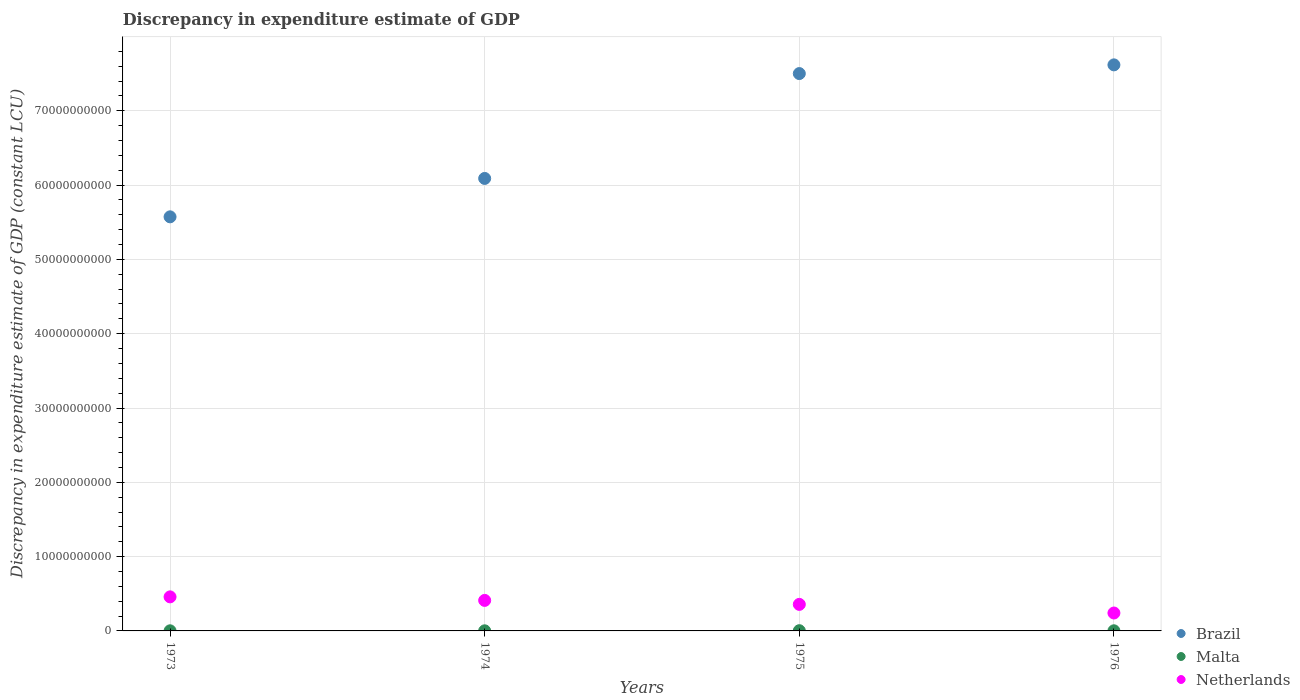How many different coloured dotlines are there?
Ensure brevity in your answer.  3. Is the number of dotlines equal to the number of legend labels?
Your answer should be very brief. Yes. What is the discrepancy in expenditure estimate of GDP in Brazil in 1973?
Your response must be concise. 5.57e+1. Across all years, what is the maximum discrepancy in expenditure estimate of GDP in Netherlands?
Your answer should be compact. 4.58e+09. Across all years, what is the minimum discrepancy in expenditure estimate of GDP in Malta?
Offer a terse response. 1.47e+07. In which year was the discrepancy in expenditure estimate of GDP in Netherlands maximum?
Offer a terse response. 1973. In which year was the discrepancy in expenditure estimate of GDP in Brazil minimum?
Provide a succinct answer. 1973. What is the total discrepancy in expenditure estimate of GDP in Brazil in the graph?
Provide a short and direct response. 2.68e+11. What is the difference between the discrepancy in expenditure estimate of GDP in Netherlands in 1973 and that in 1975?
Offer a terse response. 1.01e+09. What is the difference between the discrepancy in expenditure estimate of GDP in Malta in 1973 and the discrepancy in expenditure estimate of GDP in Netherlands in 1974?
Keep it short and to the point. -4.09e+09. What is the average discrepancy in expenditure estimate of GDP in Netherlands per year?
Ensure brevity in your answer.  3.67e+09. In the year 1976, what is the difference between the discrepancy in expenditure estimate of GDP in Netherlands and discrepancy in expenditure estimate of GDP in Brazil?
Offer a very short reply. -7.38e+1. In how many years, is the discrepancy in expenditure estimate of GDP in Netherlands greater than 66000000000 LCU?
Your response must be concise. 0. What is the ratio of the discrepancy in expenditure estimate of GDP in Malta in 1975 to that in 1976?
Your answer should be very brief. 1.71. Is the difference between the discrepancy in expenditure estimate of GDP in Netherlands in 1973 and 1974 greater than the difference between the discrepancy in expenditure estimate of GDP in Brazil in 1973 and 1974?
Provide a short and direct response. Yes. What is the difference between the highest and the second highest discrepancy in expenditure estimate of GDP in Netherlands?
Keep it short and to the point. 4.76e+08. What is the difference between the highest and the lowest discrepancy in expenditure estimate of GDP in Malta?
Keep it short and to the point. 1.52e+07. In how many years, is the discrepancy in expenditure estimate of GDP in Malta greater than the average discrepancy in expenditure estimate of GDP in Malta taken over all years?
Offer a terse response. 1. Is the sum of the discrepancy in expenditure estimate of GDP in Malta in 1974 and 1976 greater than the maximum discrepancy in expenditure estimate of GDP in Netherlands across all years?
Make the answer very short. No. Is the discrepancy in expenditure estimate of GDP in Netherlands strictly less than the discrepancy in expenditure estimate of GDP in Malta over the years?
Ensure brevity in your answer.  No. How many years are there in the graph?
Your answer should be very brief. 4. Does the graph contain any zero values?
Offer a terse response. No. Does the graph contain grids?
Your answer should be very brief. Yes. Where does the legend appear in the graph?
Ensure brevity in your answer.  Bottom right. How many legend labels are there?
Ensure brevity in your answer.  3. How are the legend labels stacked?
Your answer should be compact. Vertical. What is the title of the graph?
Keep it short and to the point. Discrepancy in expenditure estimate of GDP. Does "Algeria" appear as one of the legend labels in the graph?
Provide a succinct answer. No. What is the label or title of the Y-axis?
Offer a terse response. Discrepancy in expenditure estimate of GDP (constant LCU). What is the Discrepancy in expenditure estimate of GDP (constant LCU) in Brazil in 1973?
Your answer should be compact. 5.57e+1. What is the Discrepancy in expenditure estimate of GDP (constant LCU) in Malta in 1973?
Offer a terse response. 1.58e+07. What is the Discrepancy in expenditure estimate of GDP (constant LCU) of Netherlands in 1973?
Offer a very short reply. 4.58e+09. What is the Discrepancy in expenditure estimate of GDP (constant LCU) in Brazil in 1974?
Provide a succinct answer. 6.09e+1. What is the Discrepancy in expenditure estimate of GDP (constant LCU) of Malta in 1974?
Offer a very short reply. 1.47e+07. What is the Discrepancy in expenditure estimate of GDP (constant LCU) of Netherlands in 1974?
Keep it short and to the point. 4.11e+09. What is the Discrepancy in expenditure estimate of GDP (constant LCU) in Brazil in 1975?
Provide a short and direct response. 7.50e+1. What is the Discrepancy in expenditure estimate of GDP (constant LCU) of Malta in 1975?
Offer a very short reply. 2.99e+07. What is the Discrepancy in expenditure estimate of GDP (constant LCU) of Netherlands in 1975?
Provide a short and direct response. 3.57e+09. What is the Discrepancy in expenditure estimate of GDP (constant LCU) of Brazil in 1976?
Provide a succinct answer. 7.62e+1. What is the Discrepancy in expenditure estimate of GDP (constant LCU) of Malta in 1976?
Provide a short and direct response. 1.75e+07. What is the Discrepancy in expenditure estimate of GDP (constant LCU) in Netherlands in 1976?
Make the answer very short. 2.41e+09. Across all years, what is the maximum Discrepancy in expenditure estimate of GDP (constant LCU) of Brazil?
Provide a short and direct response. 7.62e+1. Across all years, what is the maximum Discrepancy in expenditure estimate of GDP (constant LCU) in Malta?
Offer a terse response. 2.99e+07. Across all years, what is the maximum Discrepancy in expenditure estimate of GDP (constant LCU) of Netherlands?
Your answer should be compact. 4.58e+09. Across all years, what is the minimum Discrepancy in expenditure estimate of GDP (constant LCU) of Brazil?
Provide a succinct answer. 5.57e+1. Across all years, what is the minimum Discrepancy in expenditure estimate of GDP (constant LCU) of Malta?
Your response must be concise. 1.47e+07. Across all years, what is the minimum Discrepancy in expenditure estimate of GDP (constant LCU) of Netherlands?
Your answer should be very brief. 2.41e+09. What is the total Discrepancy in expenditure estimate of GDP (constant LCU) in Brazil in the graph?
Give a very brief answer. 2.68e+11. What is the total Discrepancy in expenditure estimate of GDP (constant LCU) in Malta in the graph?
Offer a very short reply. 7.80e+07. What is the total Discrepancy in expenditure estimate of GDP (constant LCU) of Netherlands in the graph?
Keep it short and to the point. 1.47e+1. What is the difference between the Discrepancy in expenditure estimate of GDP (constant LCU) in Brazil in 1973 and that in 1974?
Your answer should be compact. -5.17e+09. What is the difference between the Discrepancy in expenditure estimate of GDP (constant LCU) in Malta in 1973 and that in 1974?
Give a very brief answer. 1.12e+06. What is the difference between the Discrepancy in expenditure estimate of GDP (constant LCU) in Netherlands in 1973 and that in 1974?
Give a very brief answer. 4.76e+08. What is the difference between the Discrepancy in expenditure estimate of GDP (constant LCU) of Brazil in 1973 and that in 1975?
Provide a succinct answer. -1.93e+1. What is the difference between the Discrepancy in expenditure estimate of GDP (constant LCU) of Malta in 1973 and that in 1975?
Your answer should be very brief. -1.41e+07. What is the difference between the Discrepancy in expenditure estimate of GDP (constant LCU) in Netherlands in 1973 and that in 1975?
Offer a very short reply. 1.01e+09. What is the difference between the Discrepancy in expenditure estimate of GDP (constant LCU) of Brazil in 1973 and that in 1976?
Make the answer very short. -2.05e+1. What is the difference between the Discrepancy in expenditure estimate of GDP (constant LCU) of Malta in 1973 and that in 1976?
Give a very brief answer. -1.66e+06. What is the difference between the Discrepancy in expenditure estimate of GDP (constant LCU) of Netherlands in 1973 and that in 1976?
Your answer should be very brief. 2.17e+09. What is the difference between the Discrepancy in expenditure estimate of GDP (constant LCU) in Brazil in 1974 and that in 1975?
Provide a succinct answer. -1.41e+1. What is the difference between the Discrepancy in expenditure estimate of GDP (constant LCU) in Malta in 1974 and that in 1975?
Offer a very short reply. -1.52e+07. What is the difference between the Discrepancy in expenditure estimate of GDP (constant LCU) of Netherlands in 1974 and that in 1975?
Give a very brief answer. 5.35e+08. What is the difference between the Discrepancy in expenditure estimate of GDP (constant LCU) of Brazil in 1974 and that in 1976?
Make the answer very short. -1.53e+1. What is the difference between the Discrepancy in expenditure estimate of GDP (constant LCU) of Malta in 1974 and that in 1976?
Keep it short and to the point. -2.79e+06. What is the difference between the Discrepancy in expenditure estimate of GDP (constant LCU) in Netherlands in 1974 and that in 1976?
Keep it short and to the point. 1.70e+09. What is the difference between the Discrepancy in expenditure estimate of GDP (constant LCU) of Brazil in 1975 and that in 1976?
Provide a succinct answer. -1.17e+09. What is the difference between the Discrepancy in expenditure estimate of GDP (constant LCU) in Malta in 1975 and that in 1976?
Your answer should be very brief. 1.24e+07. What is the difference between the Discrepancy in expenditure estimate of GDP (constant LCU) in Netherlands in 1975 and that in 1976?
Give a very brief answer. 1.16e+09. What is the difference between the Discrepancy in expenditure estimate of GDP (constant LCU) in Brazil in 1973 and the Discrepancy in expenditure estimate of GDP (constant LCU) in Malta in 1974?
Your answer should be compact. 5.57e+1. What is the difference between the Discrepancy in expenditure estimate of GDP (constant LCU) of Brazil in 1973 and the Discrepancy in expenditure estimate of GDP (constant LCU) of Netherlands in 1974?
Give a very brief answer. 5.16e+1. What is the difference between the Discrepancy in expenditure estimate of GDP (constant LCU) of Malta in 1973 and the Discrepancy in expenditure estimate of GDP (constant LCU) of Netherlands in 1974?
Provide a succinct answer. -4.09e+09. What is the difference between the Discrepancy in expenditure estimate of GDP (constant LCU) in Brazil in 1973 and the Discrepancy in expenditure estimate of GDP (constant LCU) in Malta in 1975?
Offer a very short reply. 5.57e+1. What is the difference between the Discrepancy in expenditure estimate of GDP (constant LCU) in Brazil in 1973 and the Discrepancy in expenditure estimate of GDP (constant LCU) in Netherlands in 1975?
Offer a terse response. 5.22e+1. What is the difference between the Discrepancy in expenditure estimate of GDP (constant LCU) in Malta in 1973 and the Discrepancy in expenditure estimate of GDP (constant LCU) in Netherlands in 1975?
Make the answer very short. -3.56e+09. What is the difference between the Discrepancy in expenditure estimate of GDP (constant LCU) of Brazil in 1973 and the Discrepancy in expenditure estimate of GDP (constant LCU) of Malta in 1976?
Offer a very short reply. 5.57e+1. What is the difference between the Discrepancy in expenditure estimate of GDP (constant LCU) of Brazil in 1973 and the Discrepancy in expenditure estimate of GDP (constant LCU) of Netherlands in 1976?
Your answer should be compact. 5.33e+1. What is the difference between the Discrepancy in expenditure estimate of GDP (constant LCU) of Malta in 1973 and the Discrepancy in expenditure estimate of GDP (constant LCU) of Netherlands in 1976?
Make the answer very short. -2.39e+09. What is the difference between the Discrepancy in expenditure estimate of GDP (constant LCU) of Brazil in 1974 and the Discrepancy in expenditure estimate of GDP (constant LCU) of Malta in 1975?
Ensure brevity in your answer.  6.09e+1. What is the difference between the Discrepancy in expenditure estimate of GDP (constant LCU) in Brazil in 1974 and the Discrepancy in expenditure estimate of GDP (constant LCU) in Netherlands in 1975?
Provide a short and direct response. 5.73e+1. What is the difference between the Discrepancy in expenditure estimate of GDP (constant LCU) of Malta in 1974 and the Discrepancy in expenditure estimate of GDP (constant LCU) of Netherlands in 1975?
Offer a very short reply. -3.56e+09. What is the difference between the Discrepancy in expenditure estimate of GDP (constant LCU) in Brazil in 1974 and the Discrepancy in expenditure estimate of GDP (constant LCU) in Malta in 1976?
Provide a succinct answer. 6.09e+1. What is the difference between the Discrepancy in expenditure estimate of GDP (constant LCU) in Brazil in 1974 and the Discrepancy in expenditure estimate of GDP (constant LCU) in Netherlands in 1976?
Offer a very short reply. 5.85e+1. What is the difference between the Discrepancy in expenditure estimate of GDP (constant LCU) in Malta in 1974 and the Discrepancy in expenditure estimate of GDP (constant LCU) in Netherlands in 1976?
Offer a terse response. -2.40e+09. What is the difference between the Discrepancy in expenditure estimate of GDP (constant LCU) in Brazil in 1975 and the Discrepancy in expenditure estimate of GDP (constant LCU) in Malta in 1976?
Offer a very short reply. 7.50e+1. What is the difference between the Discrepancy in expenditure estimate of GDP (constant LCU) in Brazil in 1975 and the Discrepancy in expenditure estimate of GDP (constant LCU) in Netherlands in 1976?
Offer a very short reply. 7.26e+1. What is the difference between the Discrepancy in expenditure estimate of GDP (constant LCU) of Malta in 1975 and the Discrepancy in expenditure estimate of GDP (constant LCU) of Netherlands in 1976?
Your answer should be very brief. -2.38e+09. What is the average Discrepancy in expenditure estimate of GDP (constant LCU) of Brazil per year?
Ensure brevity in your answer.  6.70e+1. What is the average Discrepancy in expenditure estimate of GDP (constant LCU) in Malta per year?
Provide a short and direct response. 1.95e+07. What is the average Discrepancy in expenditure estimate of GDP (constant LCU) of Netherlands per year?
Give a very brief answer. 3.67e+09. In the year 1973, what is the difference between the Discrepancy in expenditure estimate of GDP (constant LCU) in Brazil and Discrepancy in expenditure estimate of GDP (constant LCU) in Malta?
Make the answer very short. 5.57e+1. In the year 1973, what is the difference between the Discrepancy in expenditure estimate of GDP (constant LCU) of Brazil and Discrepancy in expenditure estimate of GDP (constant LCU) of Netherlands?
Provide a short and direct response. 5.11e+1. In the year 1973, what is the difference between the Discrepancy in expenditure estimate of GDP (constant LCU) of Malta and Discrepancy in expenditure estimate of GDP (constant LCU) of Netherlands?
Provide a short and direct response. -4.57e+09. In the year 1974, what is the difference between the Discrepancy in expenditure estimate of GDP (constant LCU) in Brazil and Discrepancy in expenditure estimate of GDP (constant LCU) in Malta?
Provide a short and direct response. 6.09e+1. In the year 1974, what is the difference between the Discrepancy in expenditure estimate of GDP (constant LCU) of Brazil and Discrepancy in expenditure estimate of GDP (constant LCU) of Netherlands?
Make the answer very short. 5.68e+1. In the year 1974, what is the difference between the Discrepancy in expenditure estimate of GDP (constant LCU) of Malta and Discrepancy in expenditure estimate of GDP (constant LCU) of Netherlands?
Keep it short and to the point. -4.09e+09. In the year 1975, what is the difference between the Discrepancy in expenditure estimate of GDP (constant LCU) in Brazil and Discrepancy in expenditure estimate of GDP (constant LCU) in Malta?
Offer a very short reply. 7.50e+1. In the year 1975, what is the difference between the Discrepancy in expenditure estimate of GDP (constant LCU) of Brazil and Discrepancy in expenditure estimate of GDP (constant LCU) of Netherlands?
Make the answer very short. 7.14e+1. In the year 1975, what is the difference between the Discrepancy in expenditure estimate of GDP (constant LCU) in Malta and Discrepancy in expenditure estimate of GDP (constant LCU) in Netherlands?
Offer a terse response. -3.54e+09. In the year 1976, what is the difference between the Discrepancy in expenditure estimate of GDP (constant LCU) in Brazil and Discrepancy in expenditure estimate of GDP (constant LCU) in Malta?
Give a very brief answer. 7.62e+1. In the year 1976, what is the difference between the Discrepancy in expenditure estimate of GDP (constant LCU) in Brazil and Discrepancy in expenditure estimate of GDP (constant LCU) in Netherlands?
Give a very brief answer. 7.38e+1. In the year 1976, what is the difference between the Discrepancy in expenditure estimate of GDP (constant LCU) in Malta and Discrepancy in expenditure estimate of GDP (constant LCU) in Netherlands?
Provide a short and direct response. -2.39e+09. What is the ratio of the Discrepancy in expenditure estimate of GDP (constant LCU) in Brazil in 1973 to that in 1974?
Offer a very short reply. 0.92. What is the ratio of the Discrepancy in expenditure estimate of GDP (constant LCU) of Malta in 1973 to that in 1974?
Your response must be concise. 1.08. What is the ratio of the Discrepancy in expenditure estimate of GDP (constant LCU) of Netherlands in 1973 to that in 1974?
Ensure brevity in your answer.  1.12. What is the ratio of the Discrepancy in expenditure estimate of GDP (constant LCU) in Brazil in 1973 to that in 1975?
Give a very brief answer. 0.74. What is the ratio of the Discrepancy in expenditure estimate of GDP (constant LCU) in Malta in 1973 to that in 1975?
Your answer should be very brief. 0.53. What is the ratio of the Discrepancy in expenditure estimate of GDP (constant LCU) of Netherlands in 1973 to that in 1975?
Your answer should be very brief. 1.28. What is the ratio of the Discrepancy in expenditure estimate of GDP (constant LCU) of Brazil in 1973 to that in 1976?
Your answer should be compact. 0.73. What is the ratio of the Discrepancy in expenditure estimate of GDP (constant LCU) of Malta in 1973 to that in 1976?
Offer a very short reply. 0.9. What is the ratio of the Discrepancy in expenditure estimate of GDP (constant LCU) of Netherlands in 1973 to that in 1976?
Make the answer very short. 1.9. What is the ratio of the Discrepancy in expenditure estimate of GDP (constant LCU) in Brazil in 1974 to that in 1975?
Make the answer very short. 0.81. What is the ratio of the Discrepancy in expenditure estimate of GDP (constant LCU) of Malta in 1974 to that in 1975?
Offer a very short reply. 0.49. What is the ratio of the Discrepancy in expenditure estimate of GDP (constant LCU) in Netherlands in 1974 to that in 1975?
Provide a short and direct response. 1.15. What is the ratio of the Discrepancy in expenditure estimate of GDP (constant LCU) in Brazil in 1974 to that in 1976?
Make the answer very short. 0.8. What is the ratio of the Discrepancy in expenditure estimate of GDP (constant LCU) in Malta in 1974 to that in 1976?
Your answer should be very brief. 0.84. What is the ratio of the Discrepancy in expenditure estimate of GDP (constant LCU) in Netherlands in 1974 to that in 1976?
Make the answer very short. 1.7. What is the ratio of the Discrepancy in expenditure estimate of GDP (constant LCU) in Brazil in 1975 to that in 1976?
Keep it short and to the point. 0.98. What is the ratio of the Discrepancy in expenditure estimate of GDP (constant LCU) in Malta in 1975 to that in 1976?
Ensure brevity in your answer.  1.71. What is the ratio of the Discrepancy in expenditure estimate of GDP (constant LCU) in Netherlands in 1975 to that in 1976?
Offer a very short reply. 1.48. What is the difference between the highest and the second highest Discrepancy in expenditure estimate of GDP (constant LCU) of Brazil?
Provide a succinct answer. 1.17e+09. What is the difference between the highest and the second highest Discrepancy in expenditure estimate of GDP (constant LCU) of Malta?
Make the answer very short. 1.24e+07. What is the difference between the highest and the second highest Discrepancy in expenditure estimate of GDP (constant LCU) in Netherlands?
Offer a terse response. 4.76e+08. What is the difference between the highest and the lowest Discrepancy in expenditure estimate of GDP (constant LCU) in Brazil?
Your response must be concise. 2.05e+1. What is the difference between the highest and the lowest Discrepancy in expenditure estimate of GDP (constant LCU) of Malta?
Your response must be concise. 1.52e+07. What is the difference between the highest and the lowest Discrepancy in expenditure estimate of GDP (constant LCU) in Netherlands?
Provide a succinct answer. 2.17e+09. 